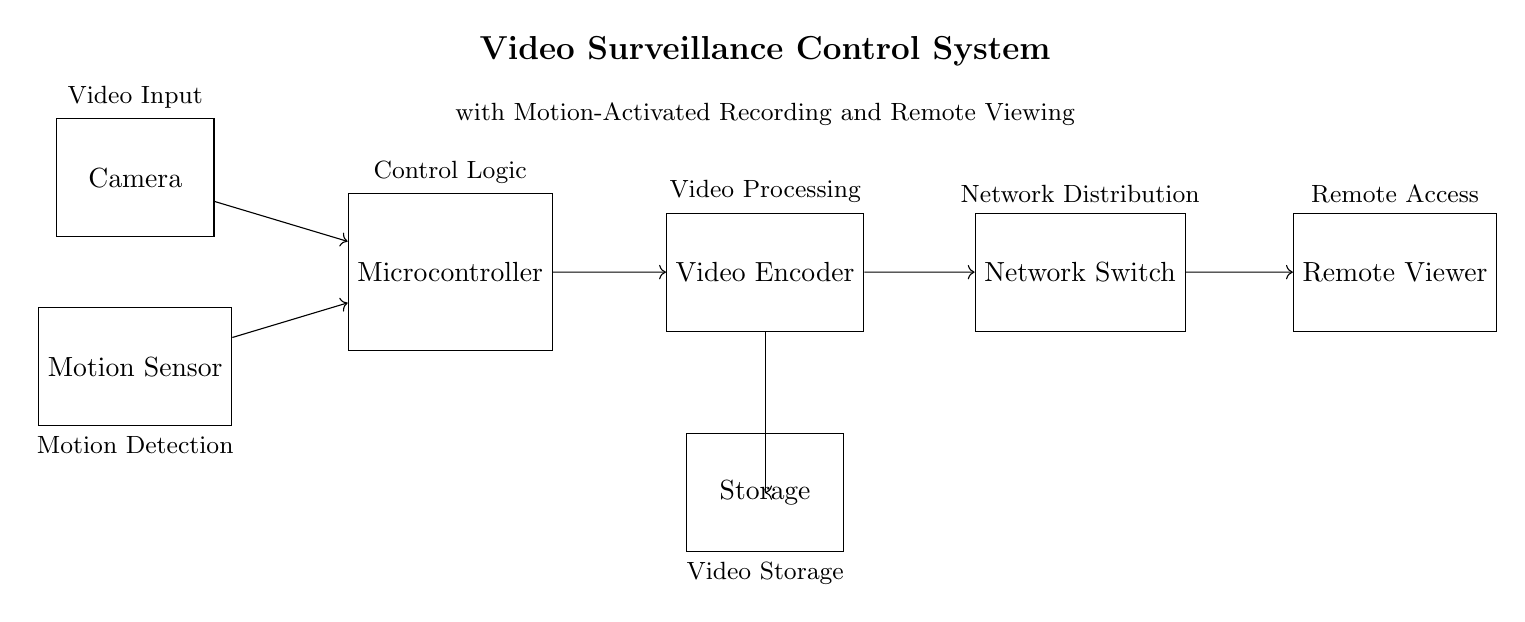What is the main component for video capture? The main component responsible for video capture in the circuit is the camera, which is designed to provide video input to the microcontroller.
Answer: Camera What device processes video signals in this circuit? The video signals are processed by the video encoder, which converts the raw video input into an encoded format suitable for transmission and storage.
Answer: Video Encoder Which component detects motion? The component that detects motion in the system is the motion sensor, which triggers recording when movement is sensed.
Answer: Motion Sensor What is the function of the microcontroller? The microcontroller serves as the control logic, coordinating between the camera, motion sensor, video encoder, and managing operations for recording and storage.
Answer: Control Logic How does video data reach the remote viewer? The video data travels through a series of connections; specifically, it moves from the encoder to the network switch and then to the remote viewer for access.
Answer: Network Switch What kind of monitoring system does this circuit implement? This circuit implements a video surveillance system equipped with motion-activated recording and remote viewing capabilities, designed to increase security and monitor areas for potential insider threats.
Answer: Video Surveillance System Which component is responsible for storing video data? The component that is responsible for storing video data is the storage unit, which retains the encoded video for later retrieval and review.
Answer: Storage 